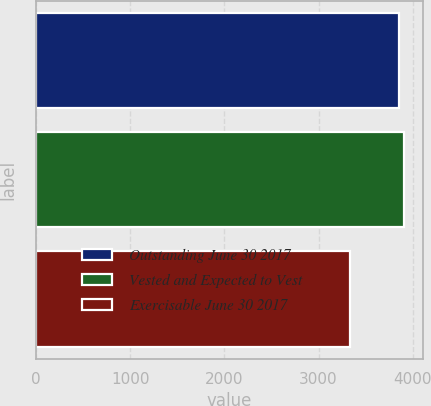Convert chart. <chart><loc_0><loc_0><loc_500><loc_500><bar_chart><fcel>Outstanding June 30 2017<fcel>Vested and Expected to Vest<fcel>Exercisable June 30 2017<nl><fcel>3859<fcel>3911.6<fcel>3333<nl></chart> 